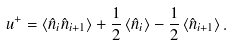<formula> <loc_0><loc_0><loc_500><loc_500>u ^ { + } = \left < \hat { n } _ { i } \hat { n } _ { i + 1 } \right > + \frac { 1 } { 2 } \left < \hat { n } _ { i } \right > - \frac { 1 } { 2 } \left < \hat { n } _ { i + 1 } \right > .</formula> 